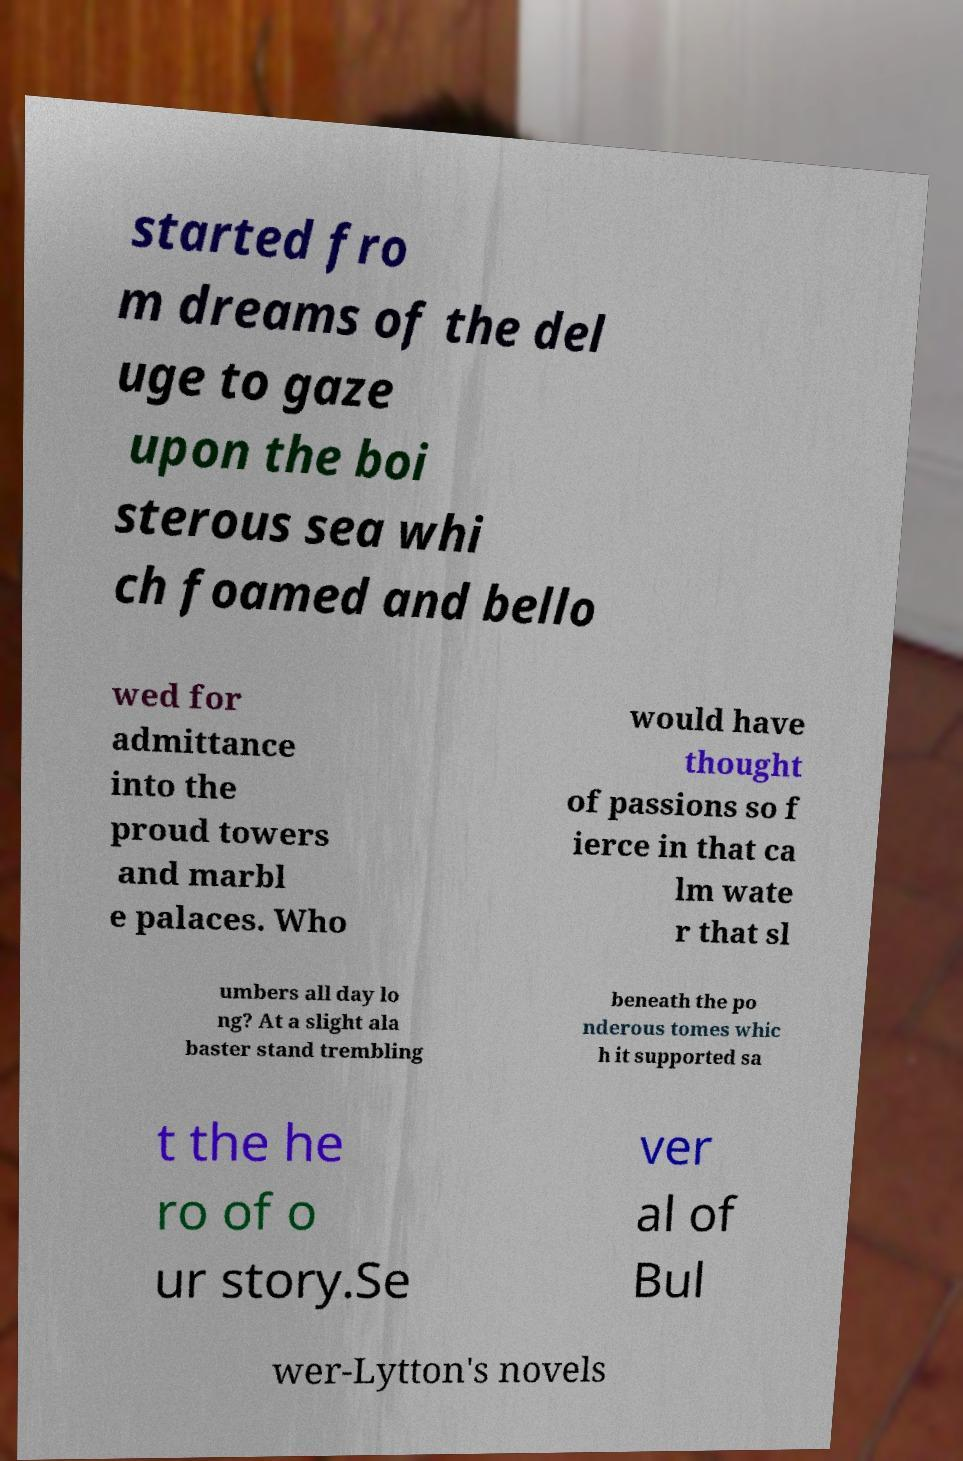Can you read and provide the text displayed in the image?This photo seems to have some interesting text. Can you extract and type it out for me? started fro m dreams of the del uge to gaze upon the boi sterous sea whi ch foamed and bello wed for admittance into the proud towers and marbl e palaces. Who would have thought of passions so f ierce in that ca lm wate r that sl umbers all day lo ng? At a slight ala baster stand trembling beneath the po nderous tomes whic h it supported sa t the he ro of o ur story.Se ver al of Bul wer-Lytton's novels 